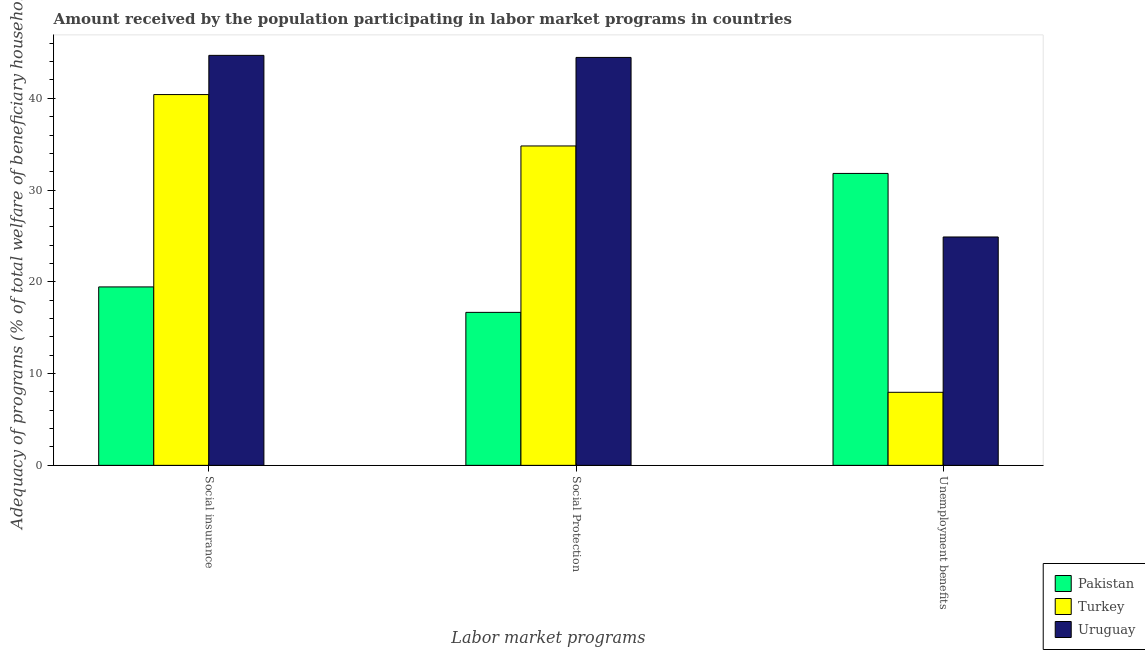How many different coloured bars are there?
Keep it short and to the point. 3. Are the number of bars per tick equal to the number of legend labels?
Your response must be concise. Yes. Are the number of bars on each tick of the X-axis equal?
Ensure brevity in your answer.  Yes. How many bars are there on the 2nd tick from the left?
Provide a succinct answer. 3. How many bars are there on the 2nd tick from the right?
Your answer should be compact. 3. What is the label of the 1st group of bars from the left?
Provide a short and direct response. Social insurance. What is the amount received by the population participating in social insurance programs in Uruguay?
Provide a succinct answer. 44.68. Across all countries, what is the maximum amount received by the population participating in unemployment benefits programs?
Offer a terse response. 31.81. Across all countries, what is the minimum amount received by the population participating in unemployment benefits programs?
Keep it short and to the point. 7.96. In which country was the amount received by the population participating in social protection programs maximum?
Keep it short and to the point. Uruguay. What is the total amount received by the population participating in social insurance programs in the graph?
Ensure brevity in your answer.  104.53. What is the difference between the amount received by the population participating in unemployment benefits programs in Uruguay and that in Pakistan?
Make the answer very short. -6.92. What is the difference between the amount received by the population participating in unemployment benefits programs in Turkey and the amount received by the population participating in social insurance programs in Uruguay?
Your answer should be compact. -36.72. What is the average amount received by the population participating in social insurance programs per country?
Offer a terse response. 34.84. What is the difference between the amount received by the population participating in unemployment benefits programs and amount received by the population participating in social insurance programs in Turkey?
Provide a succinct answer. -32.45. What is the ratio of the amount received by the population participating in social insurance programs in Turkey to that in Uruguay?
Your answer should be compact. 0.9. What is the difference between the highest and the second highest amount received by the population participating in social insurance programs?
Make the answer very short. 4.27. What is the difference between the highest and the lowest amount received by the population participating in social protection programs?
Provide a succinct answer. 27.78. In how many countries, is the amount received by the population participating in unemployment benefits programs greater than the average amount received by the population participating in unemployment benefits programs taken over all countries?
Ensure brevity in your answer.  2. What does the 3rd bar from the left in Social insurance represents?
Ensure brevity in your answer.  Uruguay. Is it the case that in every country, the sum of the amount received by the population participating in social insurance programs and amount received by the population participating in social protection programs is greater than the amount received by the population participating in unemployment benefits programs?
Provide a succinct answer. Yes. How many bars are there?
Provide a short and direct response. 9. How many countries are there in the graph?
Keep it short and to the point. 3. Are the values on the major ticks of Y-axis written in scientific E-notation?
Your response must be concise. No. Does the graph contain grids?
Offer a terse response. No. How many legend labels are there?
Keep it short and to the point. 3. What is the title of the graph?
Ensure brevity in your answer.  Amount received by the population participating in labor market programs in countries. Does "Turkey" appear as one of the legend labels in the graph?
Offer a very short reply. Yes. What is the label or title of the X-axis?
Ensure brevity in your answer.  Labor market programs. What is the label or title of the Y-axis?
Give a very brief answer. Adequacy of programs (% of total welfare of beneficiary households). What is the Adequacy of programs (% of total welfare of beneficiary households) of Pakistan in Social insurance?
Offer a very short reply. 19.44. What is the Adequacy of programs (% of total welfare of beneficiary households) in Turkey in Social insurance?
Make the answer very short. 40.41. What is the Adequacy of programs (% of total welfare of beneficiary households) in Uruguay in Social insurance?
Provide a short and direct response. 44.68. What is the Adequacy of programs (% of total welfare of beneficiary households) in Pakistan in Social Protection?
Provide a succinct answer. 16.67. What is the Adequacy of programs (% of total welfare of beneficiary households) of Turkey in Social Protection?
Provide a succinct answer. 34.81. What is the Adequacy of programs (% of total welfare of beneficiary households) in Uruguay in Social Protection?
Offer a terse response. 44.45. What is the Adequacy of programs (% of total welfare of beneficiary households) in Pakistan in Unemployment benefits?
Your answer should be compact. 31.81. What is the Adequacy of programs (% of total welfare of beneficiary households) in Turkey in Unemployment benefits?
Provide a succinct answer. 7.96. What is the Adequacy of programs (% of total welfare of beneficiary households) of Uruguay in Unemployment benefits?
Make the answer very short. 24.89. Across all Labor market programs, what is the maximum Adequacy of programs (% of total welfare of beneficiary households) in Pakistan?
Your response must be concise. 31.81. Across all Labor market programs, what is the maximum Adequacy of programs (% of total welfare of beneficiary households) of Turkey?
Give a very brief answer. 40.41. Across all Labor market programs, what is the maximum Adequacy of programs (% of total welfare of beneficiary households) of Uruguay?
Offer a very short reply. 44.68. Across all Labor market programs, what is the minimum Adequacy of programs (% of total welfare of beneficiary households) of Pakistan?
Make the answer very short. 16.67. Across all Labor market programs, what is the minimum Adequacy of programs (% of total welfare of beneficiary households) in Turkey?
Your answer should be very brief. 7.96. Across all Labor market programs, what is the minimum Adequacy of programs (% of total welfare of beneficiary households) in Uruguay?
Keep it short and to the point. 24.89. What is the total Adequacy of programs (% of total welfare of beneficiary households) in Pakistan in the graph?
Give a very brief answer. 67.93. What is the total Adequacy of programs (% of total welfare of beneficiary households) in Turkey in the graph?
Provide a succinct answer. 83.17. What is the total Adequacy of programs (% of total welfare of beneficiary households) of Uruguay in the graph?
Keep it short and to the point. 114.02. What is the difference between the Adequacy of programs (% of total welfare of beneficiary households) in Pakistan in Social insurance and that in Social Protection?
Ensure brevity in your answer.  2.77. What is the difference between the Adequacy of programs (% of total welfare of beneficiary households) of Turkey in Social insurance and that in Social Protection?
Ensure brevity in your answer.  5.6. What is the difference between the Adequacy of programs (% of total welfare of beneficiary households) of Uruguay in Social insurance and that in Social Protection?
Provide a short and direct response. 0.22. What is the difference between the Adequacy of programs (% of total welfare of beneficiary households) in Pakistan in Social insurance and that in Unemployment benefits?
Your response must be concise. -12.37. What is the difference between the Adequacy of programs (% of total welfare of beneficiary households) of Turkey in Social insurance and that in Unemployment benefits?
Keep it short and to the point. 32.45. What is the difference between the Adequacy of programs (% of total welfare of beneficiary households) in Uruguay in Social insurance and that in Unemployment benefits?
Provide a short and direct response. 19.79. What is the difference between the Adequacy of programs (% of total welfare of beneficiary households) in Pakistan in Social Protection and that in Unemployment benefits?
Your response must be concise. -15.14. What is the difference between the Adequacy of programs (% of total welfare of beneficiary households) of Turkey in Social Protection and that in Unemployment benefits?
Keep it short and to the point. 26.85. What is the difference between the Adequacy of programs (% of total welfare of beneficiary households) in Uruguay in Social Protection and that in Unemployment benefits?
Your answer should be compact. 19.57. What is the difference between the Adequacy of programs (% of total welfare of beneficiary households) in Pakistan in Social insurance and the Adequacy of programs (% of total welfare of beneficiary households) in Turkey in Social Protection?
Provide a succinct answer. -15.36. What is the difference between the Adequacy of programs (% of total welfare of beneficiary households) of Pakistan in Social insurance and the Adequacy of programs (% of total welfare of beneficiary households) of Uruguay in Social Protection?
Offer a terse response. -25.01. What is the difference between the Adequacy of programs (% of total welfare of beneficiary households) of Turkey in Social insurance and the Adequacy of programs (% of total welfare of beneficiary households) of Uruguay in Social Protection?
Provide a short and direct response. -4.05. What is the difference between the Adequacy of programs (% of total welfare of beneficiary households) of Pakistan in Social insurance and the Adequacy of programs (% of total welfare of beneficiary households) of Turkey in Unemployment benefits?
Provide a short and direct response. 11.48. What is the difference between the Adequacy of programs (% of total welfare of beneficiary households) of Pakistan in Social insurance and the Adequacy of programs (% of total welfare of beneficiary households) of Uruguay in Unemployment benefits?
Your response must be concise. -5.44. What is the difference between the Adequacy of programs (% of total welfare of beneficiary households) in Turkey in Social insurance and the Adequacy of programs (% of total welfare of beneficiary households) in Uruguay in Unemployment benefits?
Offer a terse response. 15.52. What is the difference between the Adequacy of programs (% of total welfare of beneficiary households) of Pakistan in Social Protection and the Adequacy of programs (% of total welfare of beneficiary households) of Turkey in Unemployment benefits?
Provide a succinct answer. 8.71. What is the difference between the Adequacy of programs (% of total welfare of beneficiary households) of Pakistan in Social Protection and the Adequacy of programs (% of total welfare of beneficiary households) of Uruguay in Unemployment benefits?
Your answer should be very brief. -8.21. What is the difference between the Adequacy of programs (% of total welfare of beneficiary households) of Turkey in Social Protection and the Adequacy of programs (% of total welfare of beneficiary households) of Uruguay in Unemployment benefits?
Offer a very short reply. 9.92. What is the average Adequacy of programs (% of total welfare of beneficiary households) of Pakistan per Labor market programs?
Provide a short and direct response. 22.64. What is the average Adequacy of programs (% of total welfare of beneficiary households) of Turkey per Labor market programs?
Your answer should be compact. 27.72. What is the average Adequacy of programs (% of total welfare of beneficiary households) in Uruguay per Labor market programs?
Make the answer very short. 38.01. What is the difference between the Adequacy of programs (% of total welfare of beneficiary households) in Pakistan and Adequacy of programs (% of total welfare of beneficiary households) in Turkey in Social insurance?
Make the answer very short. -20.96. What is the difference between the Adequacy of programs (% of total welfare of beneficiary households) in Pakistan and Adequacy of programs (% of total welfare of beneficiary households) in Uruguay in Social insurance?
Offer a very short reply. -25.23. What is the difference between the Adequacy of programs (% of total welfare of beneficiary households) in Turkey and Adequacy of programs (% of total welfare of beneficiary households) in Uruguay in Social insurance?
Your response must be concise. -4.27. What is the difference between the Adequacy of programs (% of total welfare of beneficiary households) of Pakistan and Adequacy of programs (% of total welfare of beneficiary households) of Turkey in Social Protection?
Offer a very short reply. -18.13. What is the difference between the Adequacy of programs (% of total welfare of beneficiary households) of Pakistan and Adequacy of programs (% of total welfare of beneficiary households) of Uruguay in Social Protection?
Offer a very short reply. -27.78. What is the difference between the Adequacy of programs (% of total welfare of beneficiary households) of Turkey and Adequacy of programs (% of total welfare of beneficiary households) of Uruguay in Social Protection?
Offer a very short reply. -9.65. What is the difference between the Adequacy of programs (% of total welfare of beneficiary households) of Pakistan and Adequacy of programs (% of total welfare of beneficiary households) of Turkey in Unemployment benefits?
Offer a terse response. 23.85. What is the difference between the Adequacy of programs (% of total welfare of beneficiary households) in Pakistan and Adequacy of programs (% of total welfare of beneficiary households) in Uruguay in Unemployment benefits?
Your answer should be very brief. 6.92. What is the difference between the Adequacy of programs (% of total welfare of beneficiary households) of Turkey and Adequacy of programs (% of total welfare of beneficiary households) of Uruguay in Unemployment benefits?
Ensure brevity in your answer.  -16.93. What is the ratio of the Adequacy of programs (% of total welfare of beneficiary households) in Pakistan in Social insurance to that in Social Protection?
Offer a terse response. 1.17. What is the ratio of the Adequacy of programs (% of total welfare of beneficiary households) in Turkey in Social insurance to that in Social Protection?
Ensure brevity in your answer.  1.16. What is the ratio of the Adequacy of programs (% of total welfare of beneficiary households) of Pakistan in Social insurance to that in Unemployment benefits?
Your answer should be very brief. 0.61. What is the ratio of the Adequacy of programs (% of total welfare of beneficiary households) of Turkey in Social insurance to that in Unemployment benefits?
Keep it short and to the point. 5.08. What is the ratio of the Adequacy of programs (% of total welfare of beneficiary households) in Uruguay in Social insurance to that in Unemployment benefits?
Give a very brief answer. 1.8. What is the ratio of the Adequacy of programs (% of total welfare of beneficiary households) in Pakistan in Social Protection to that in Unemployment benefits?
Provide a succinct answer. 0.52. What is the ratio of the Adequacy of programs (% of total welfare of beneficiary households) in Turkey in Social Protection to that in Unemployment benefits?
Provide a succinct answer. 4.37. What is the ratio of the Adequacy of programs (% of total welfare of beneficiary households) in Uruguay in Social Protection to that in Unemployment benefits?
Make the answer very short. 1.79. What is the difference between the highest and the second highest Adequacy of programs (% of total welfare of beneficiary households) in Pakistan?
Keep it short and to the point. 12.37. What is the difference between the highest and the second highest Adequacy of programs (% of total welfare of beneficiary households) of Turkey?
Offer a very short reply. 5.6. What is the difference between the highest and the second highest Adequacy of programs (% of total welfare of beneficiary households) in Uruguay?
Make the answer very short. 0.22. What is the difference between the highest and the lowest Adequacy of programs (% of total welfare of beneficiary households) in Pakistan?
Make the answer very short. 15.14. What is the difference between the highest and the lowest Adequacy of programs (% of total welfare of beneficiary households) in Turkey?
Provide a short and direct response. 32.45. What is the difference between the highest and the lowest Adequacy of programs (% of total welfare of beneficiary households) of Uruguay?
Your response must be concise. 19.79. 